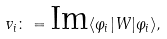Convert formula to latex. <formula><loc_0><loc_0><loc_500><loc_500>v _ { i } \colon = \text {Im} \langle \varphi _ { i } | W | \varphi _ { i } \rangle ,</formula> 